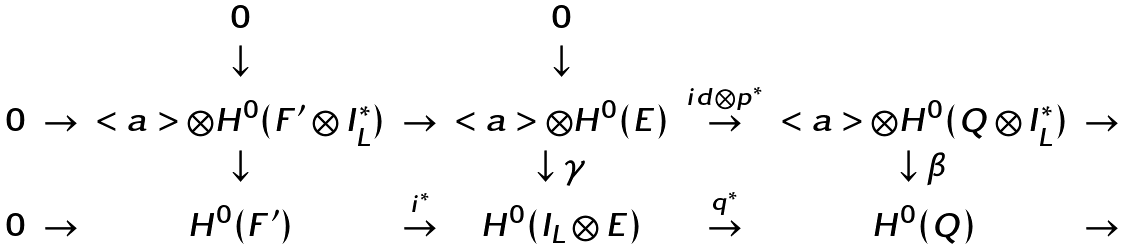Convert formula to latex. <formula><loc_0><loc_0><loc_500><loc_500>\begin{array} { c c c c c c c c c } & & 0 & & 0 & & & & \\ & & \downarrow & & \downarrow & & & & \\ 0 & \rightarrow & < a > \otimes H ^ { 0 } ( F ^ { \prime } \otimes I _ { L } ^ { * } ) & \rightarrow & < a > \otimes H ^ { 0 } ( E ) & \stackrel { i d \otimes p ^ { * } } { \rightarrow } & < a > \otimes H ^ { 0 } ( Q \otimes I _ { L } ^ { * } ) & \rightarrow & \\ & & \downarrow & & \downarrow \gamma & & \downarrow \beta & & \\ 0 & \rightarrow & H ^ { 0 } ( F ^ { \prime } ) & \stackrel { i ^ { * } } { \rightarrow } & H ^ { 0 } ( I _ { L } \otimes E ) & \stackrel { q ^ { * } } { \rightarrow } & H ^ { 0 } ( Q ) & \rightarrow & \\ \end{array}</formula> 